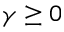Convert formula to latex. <formula><loc_0><loc_0><loc_500><loc_500>\gamma \geq 0</formula> 